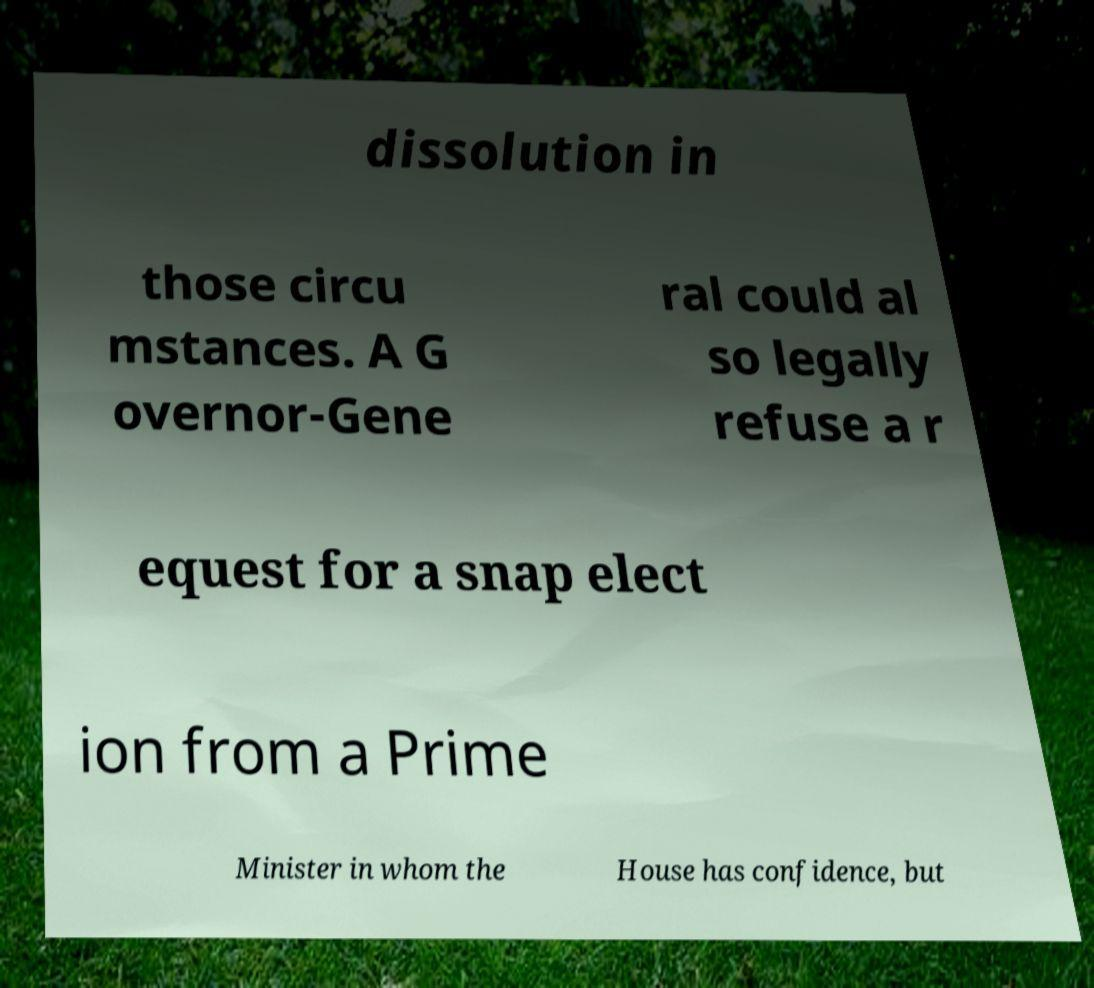I need the written content from this picture converted into text. Can you do that? dissolution in those circu mstances. A G overnor-Gene ral could al so legally refuse a r equest for a snap elect ion from a Prime Minister in whom the House has confidence, but 